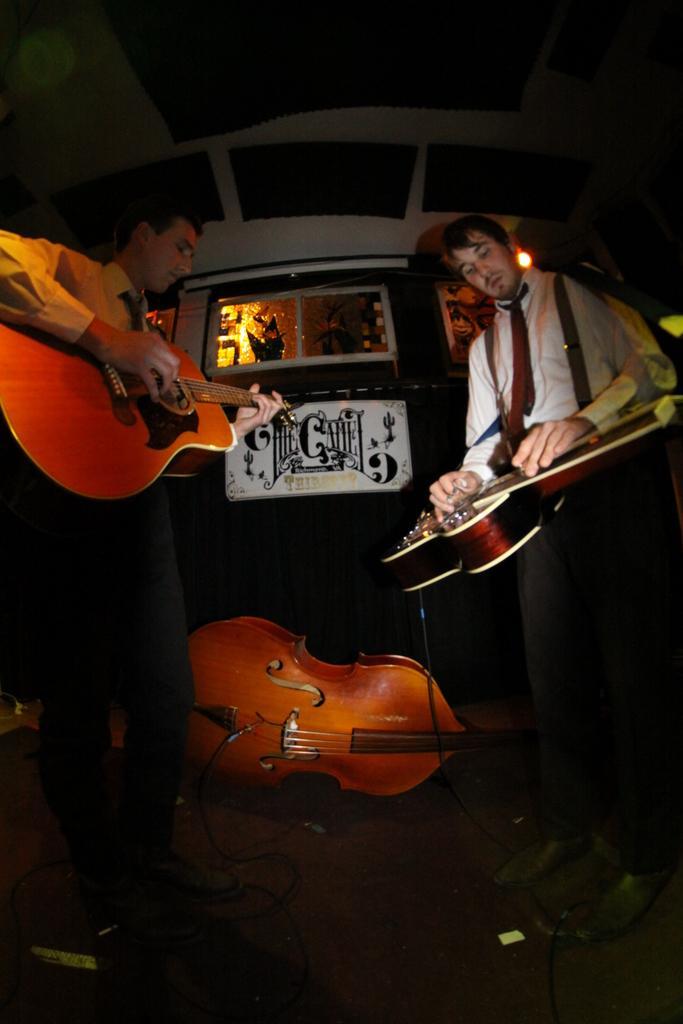Can you describe this image briefly? In the image we can see two persons were standing and holding guitar. In the center we can see one guitar. in the background there is a wall,light,window,banner and wires. 